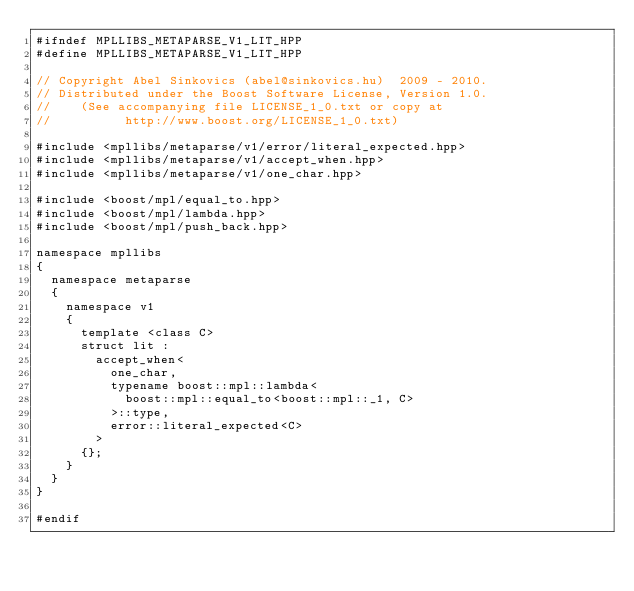Convert code to text. <code><loc_0><loc_0><loc_500><loc_500><_C++_>#ifndef MPLLIBS_METAPARSE_V1_LIT_HPP
#define MPLLIBS_METAPARSE_V1_LIT_HPP

// Copyright Abel Sinkovics (abel@sinkovics.hu)  2009 - 2010.
// Distributed under the Boost Software License, Version 1.0.
//    (See accompanying file LICENSE_1_0.txt or copy at
//          http://www.boost.org/LICENSE_1_0.txt)

#include <mpllibs/metaparse/v1/error/literal_expected.hpp>
#include <mpllibs/metaparse/v1/accept_when.hpp>
#include <mpllibs/metaparse/v1/one_char.hpp>

#include <boost/mpl/equal_to.hpp>
#include <boost/mpl/lambda.hpp>
#include <boost/mpl/push_back.hpp>

namespace mpllibs
{
  namespace metaparse
  {
    namespace v1
    {
      template <class C>
      struct lit :
        accept_when<
          one_char,
          typename boost::mpl::lambda<
            boost::mpl::equal_to<boost::mpl::_1, C>
          >::type,
          error::literal_expected<C>
        >
      {};
    }
  }
}

#endif


</code> 